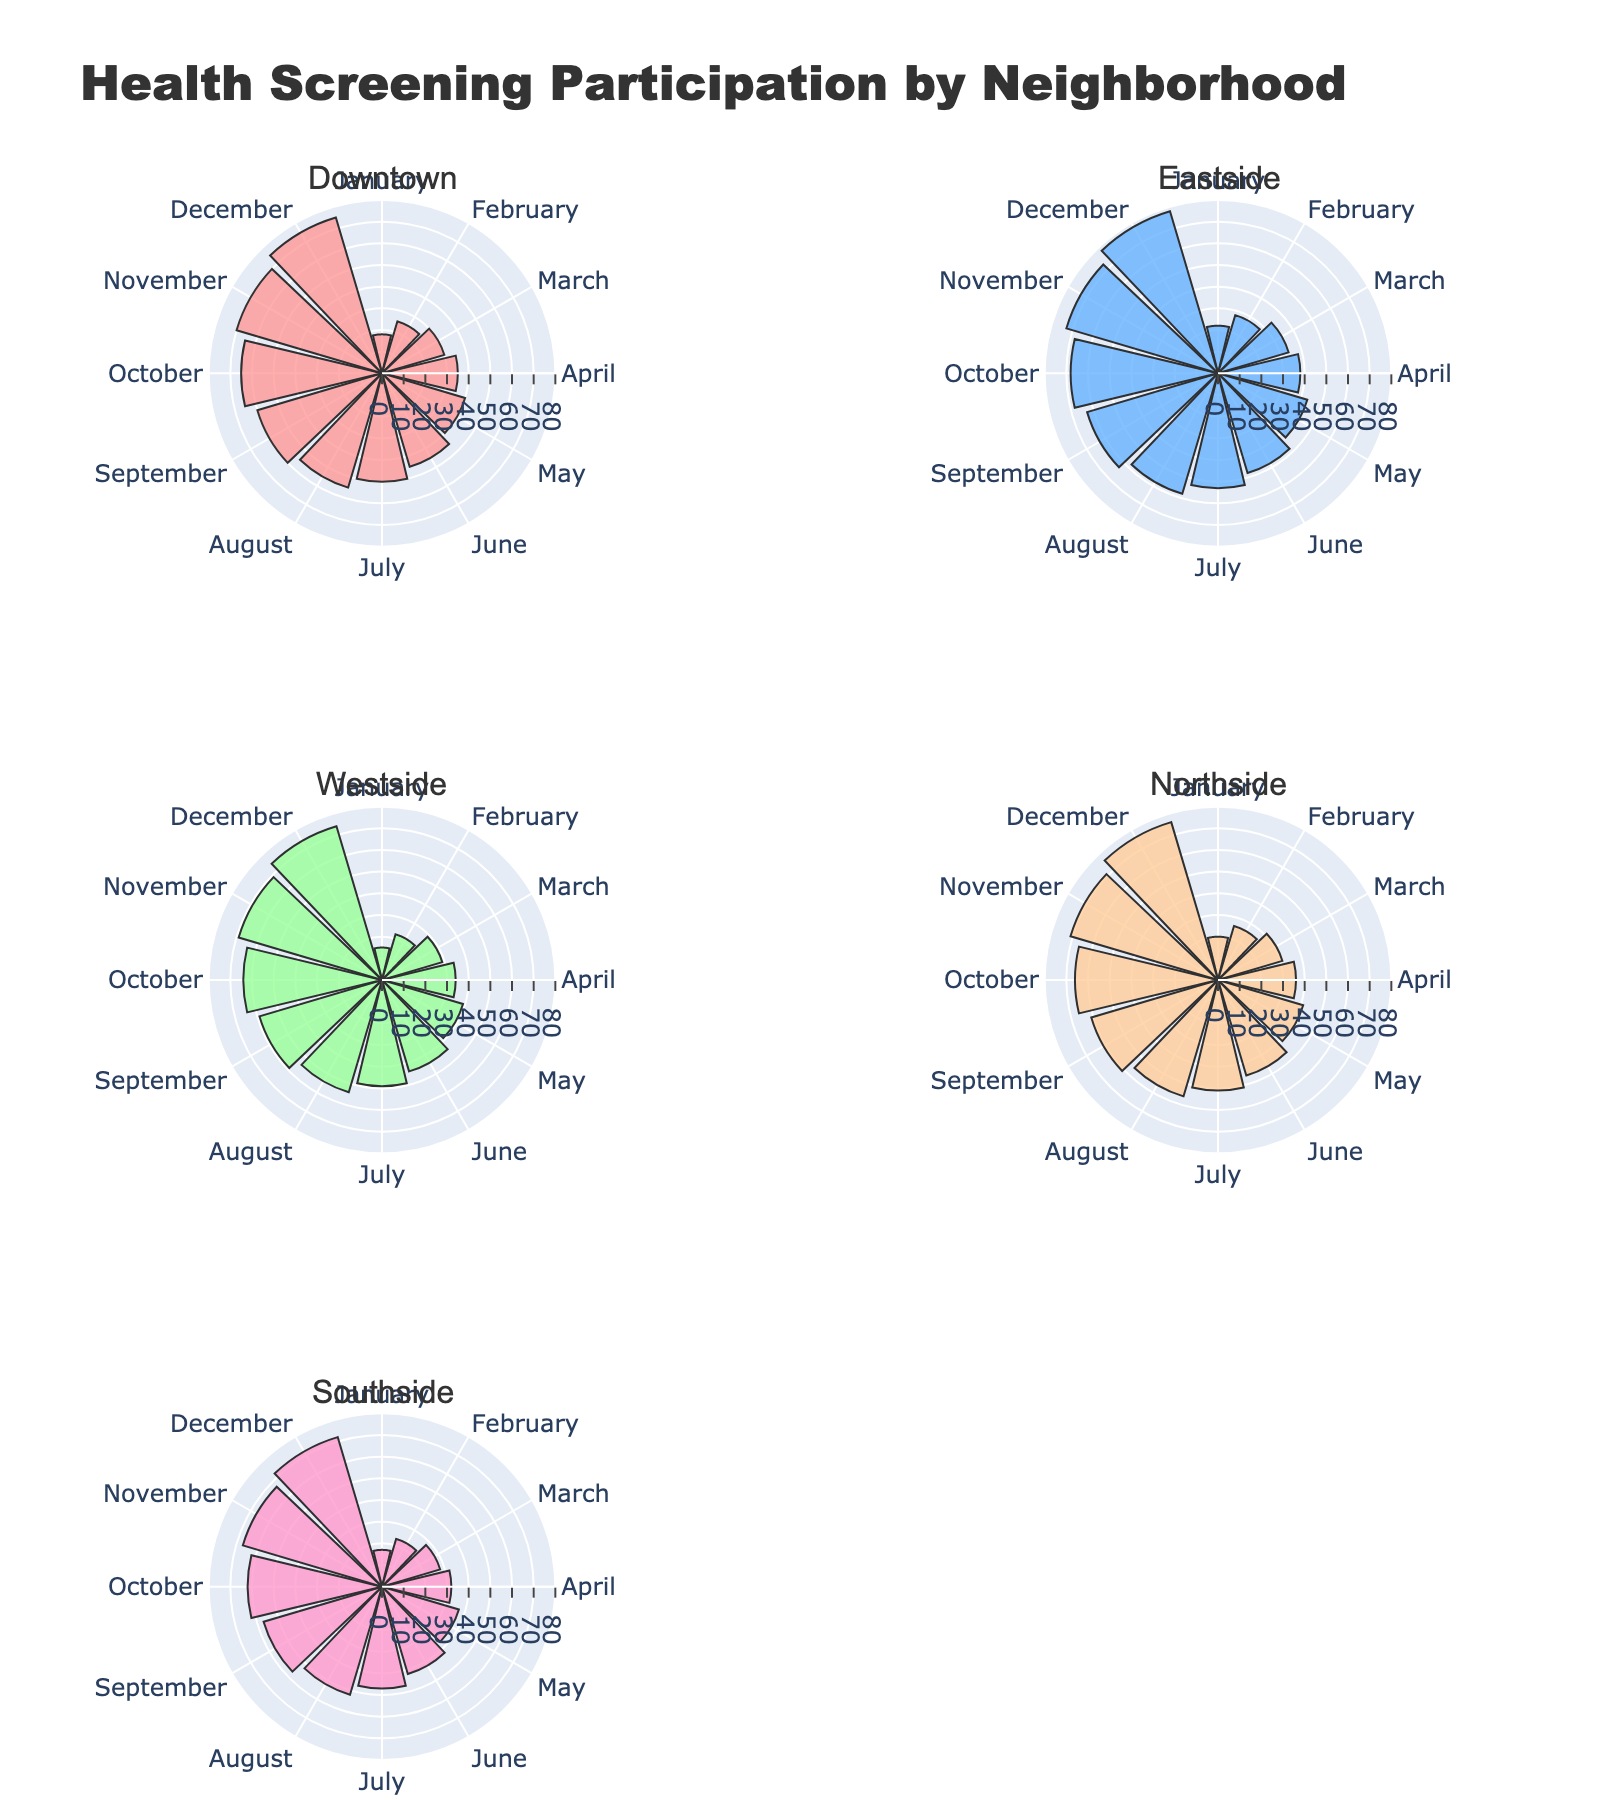How many neighborhoods are represented in the figure? The subplot titles in the figure represent the neighborhoods. By simply counting the number of subplot titles, it's evident there are five neighborhoods: Downtown, Eastside, Westside, Northside, and Southside.
Answer: 5 Which neighborhood showed the highest participation percentage in December? The figure for each neighborhood contains a polar bar plot with the months as angles and participation percentages as radii. By comparing the bars for December, the highest one is in Eastside.
Answer: Eastside What is the participation percentage for Northside in May? Locate the Northside subplot and check the radial bar for May. The percentage is labeled on the bar corresponding to May.
Answer: 41% Marking the highest increase in participation from January to December, which neighborhood shows most improvement? Review the figure and compare the bar lengths for January and December for each neighborhood. Calculate the difference for each, finding Eastside has the largest improvement (78-22 = 56).
Answer: Eastside What is the overall trend in health screening participation across all neighborhoods over the months? Each subplot shows a steady increase in the length of the bars from January through December, demonstrating a consistent increase in participation across all neighborhoods.
Answer: Increasing Which month and neighborhood had the lowest participation rate? Scan each subplot for the shortest bar. The shortest bar is in the Westside subplot for January.
Answer: January, Westside Does any neighborhood have the same participation percentage in two different months? Check each subplot to compare the heights of bars. There is no instance where a neighborhood has the same participation percentage in two different months.
Answer: No What is the difference in participation percentage between February and November for Southside? Check Southside’s subplot and locate the bars for February (23%) and November (67%). Subtract February's percentage from November's (67 - 23 = 44).
Answer: 44 Which neighborhood showed the most consistent increase in participation month over month? Compare each subplot to see the smoothness and consistency of the bar height increases. All neighborhoods exhibit consistent monthly increases, but Downtown has a very smooth trend.
Answer: Downtown Name the neighborhood with the highest participation percentage for August and its corresponding percentage. Review the bar heights for August in each subplot. Eastside has the highest bar for August at 58%.
Answer: Eastside, 58% 